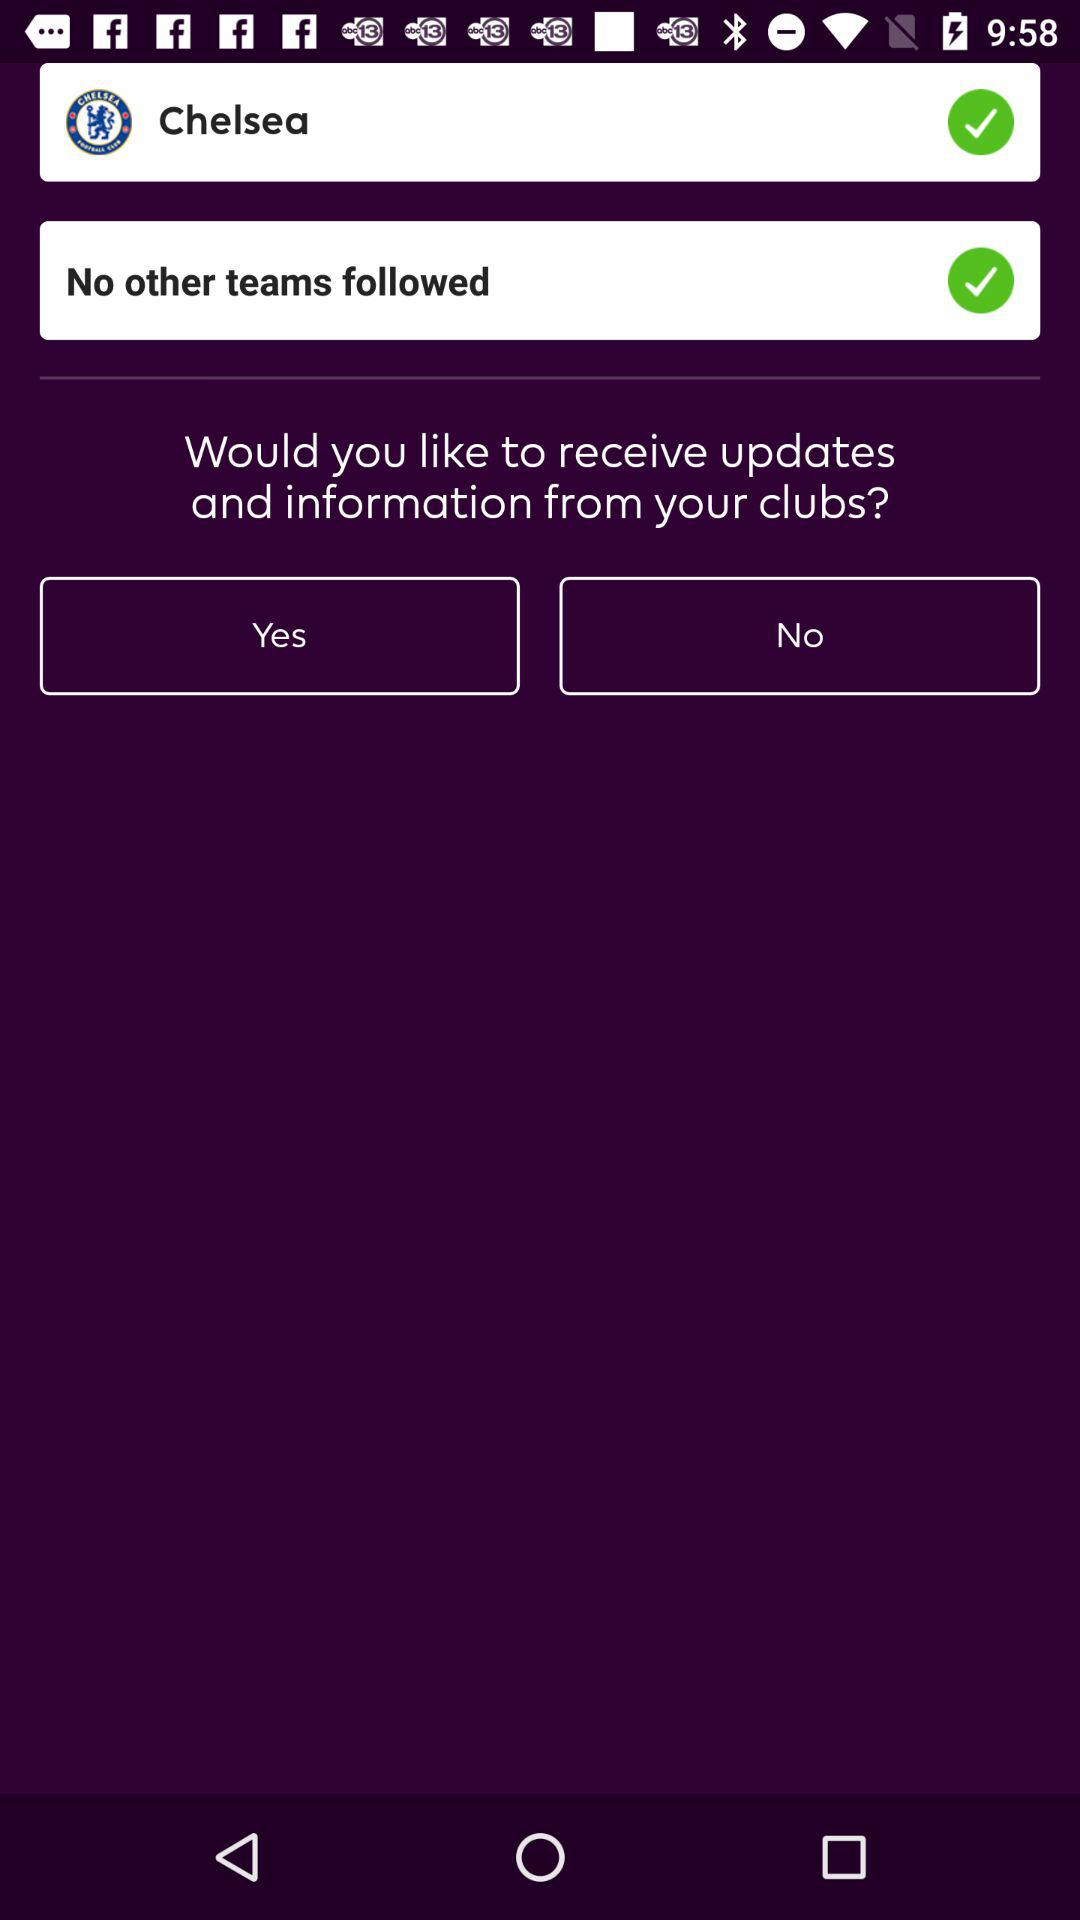What is the name of the application?
When the provided information is insufficient, respond with <no answer>. <no answer> 